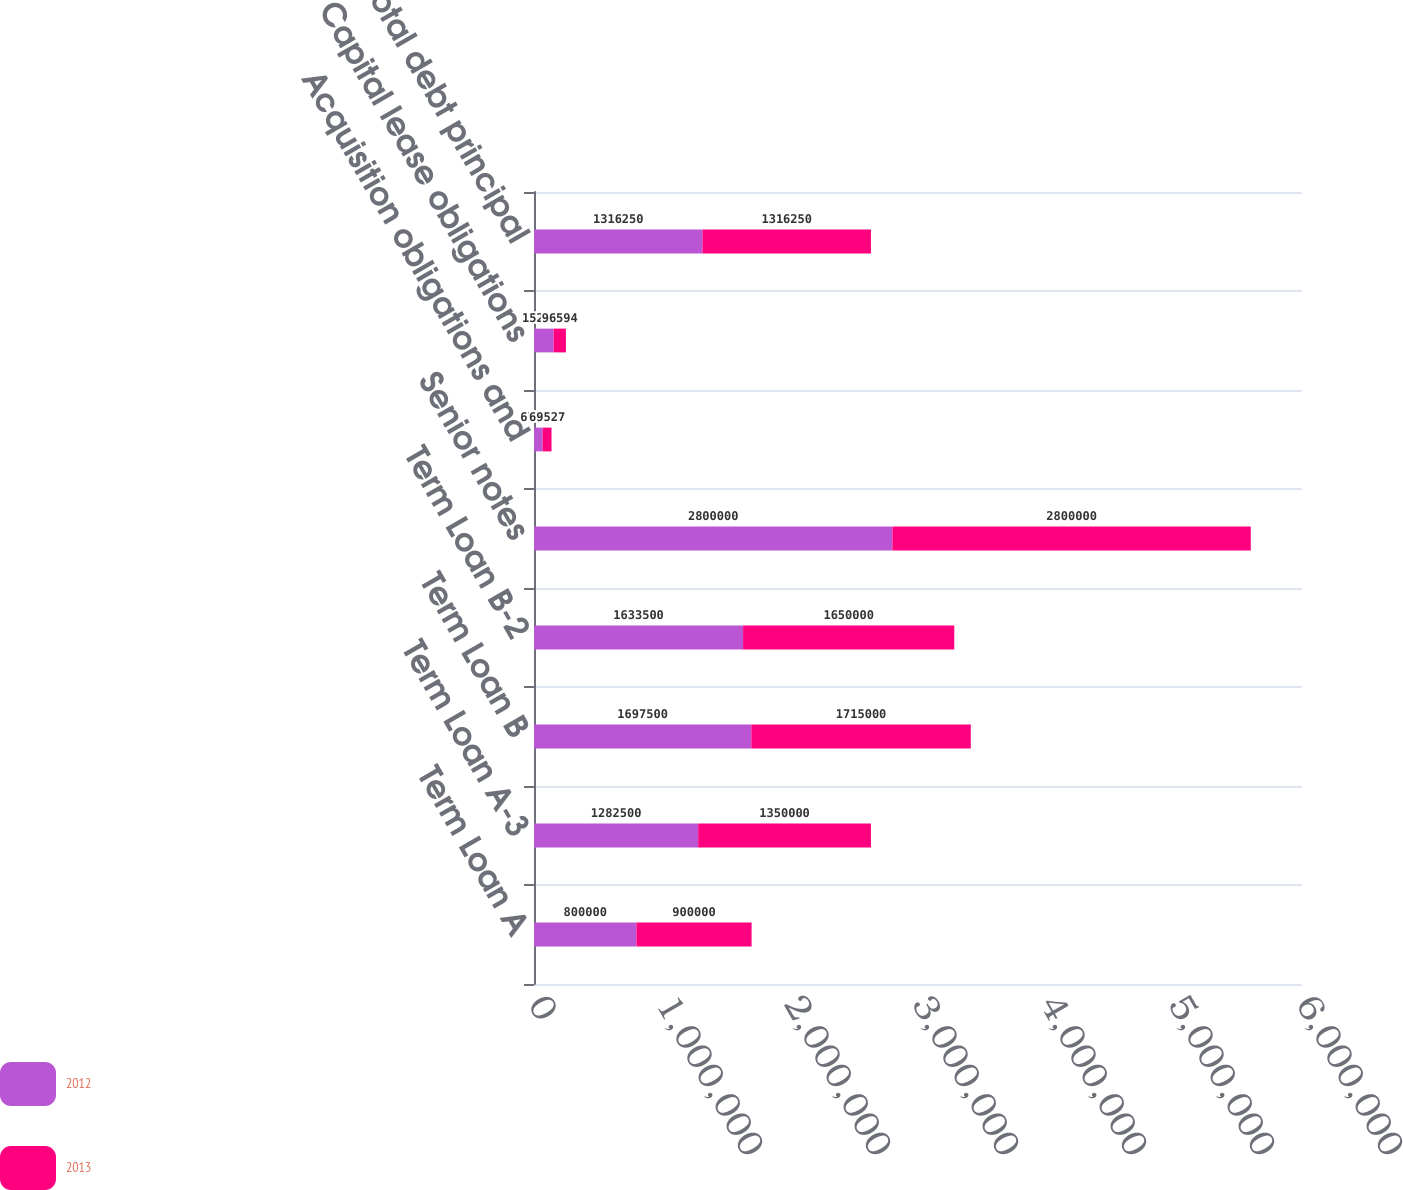Convert chart to OTSL. <chart><loc_0><loc_0><loc_500><loc_500><stacked_bar_chart><ecel><fcel>Term Loan A<fcel>Term Loan A-3<fcel>Term Loan B<fcel>Term Loan B-2<fcel>Senior notes<fcel>Acquisition obligations and<fcel>Capital lease obligations<fcel>Total debt principal<nl><fcel>2012<fcel>800000<fcel>1.2825e+06<fcel>1.6975e+06<fcel>1.6335e+06<fcel>2.8e+06<fcel>67352<fcel>152751<fcel>1.31625e+06<nl><fcel>2013<fcel>900000<fcel>1.35e+06<fcel>1.715e+06<fcel>1.65e+06<fcel>2.8e+06<fcel>69527<fcel>96594<fcel>1.31625e+06<nl></chart> 